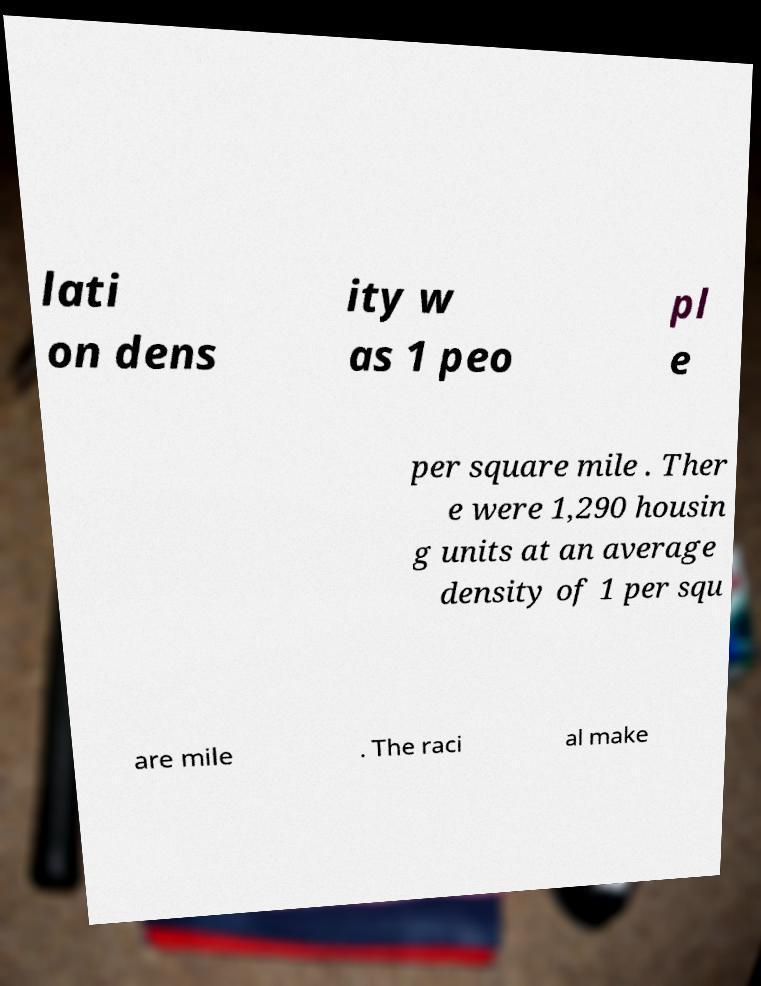I need the written content from this picture converted into text. Can you do that? lati on dens ity w as 1 peo pl e per square mile . Ther e were 1,290 housin g units at an average density of 1 per squ are mile . The raci al make 